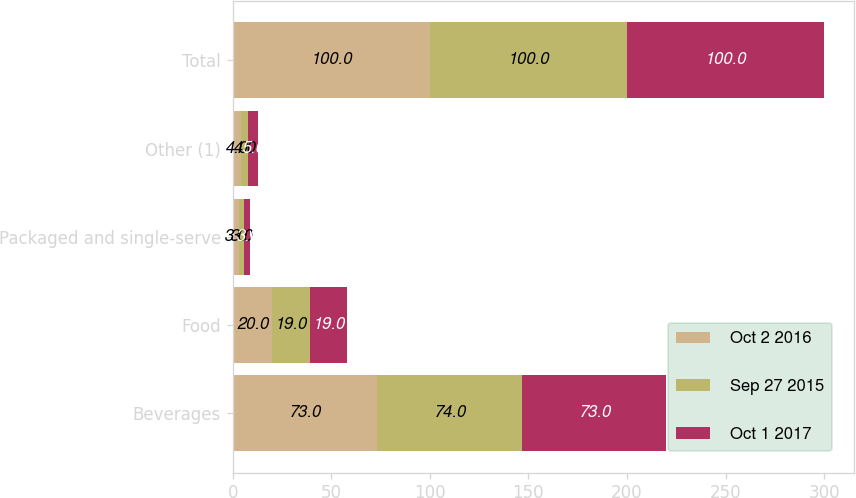<chart> <loc_0><loc_0><loc_500><loc_500><stacked_bar_chart><ecel><fcel>Beverages<fcel>Food<fcel>Packaged and single-serve<fcel>Other (1)<fcel>Total<nl><fcel>Oct 2 2016<fcel>73<fcel>20<fcel>3<fcel>4<fcel>100<nl><fcel>Sep 27 2015<fcel>74<fcel>19<fcel>3<fcel>4<fcel>100<nl><fcel>Oct 1 2017<fcel>73<fcel>19<fcel>3<fcel>5<fcel>100<nl></chart> 